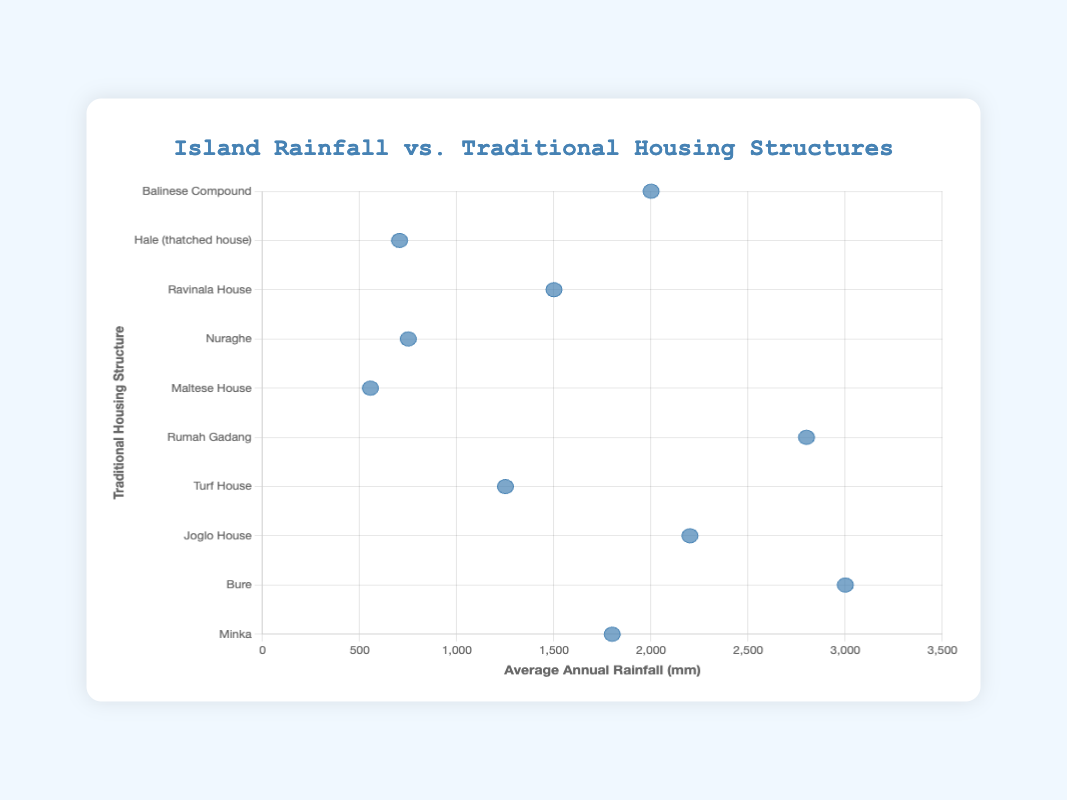What's the title of the chart? The title is prominently displayed at the top center of the chart, reading "Island Rainfall vs. Traditional Housing Structures".
Answer: Island Rainfall vs. Traditional Housing Structures What measurement is represented on the x-axis? The x-axis title reads "Average Annual Rainfall (mm)", indicating that it measures the average annual rainfall in millimeters.
Answer: Average Annual Rainfall (mm) Which traditional housing structure is associated with the highest average annual rainfall? The housing structure labeled "Bure" is at the highest position on the x-axis, which corresponds to Fiji with 3000 mm of rainfall.
Answer: Bure List the islands that have an average annual rainfall greater than 2000 mm. By checking the data points to the right of the 2000 mm mark, the islands are Sumatra (2800 mm), Java (2200 mm), and Fiji (3000 mm).
Answer: Sumatra, Java, Fiji Which island's traditional housing structure has the lowest average annual rainfall? The data point closest to zero on the x-axis represents the "Maltese House" for Malta, with 555 mm of rainfall.
Answer: Malta Is there any island with similar average annual rainfall to Sardinia? If yes, name it. Sardinia's average annual rainfall is 750 mm. The island closest to this value is Honolulu with 705 mm, as both are positioned similarly on the x-axis.
Answer: Honolulu What is the average annual rainfall for the island having a traditional housing structure known as "Minka"? Refer to the "Minka" data point, which corresponds to Kyushu with an average annual rainfall of 1800 mm.
Answer: 1800 mm Compare the average annual rainfall between Iceland and Madagascar. Which island receives more rainfall? The "Turf House" representing Iceland is at 1250 mm, and the "Ravinala House" representing Madagascar is at 1500 mm. Therefore, Madagascar receives more rainfall.
Answer: Madagascar Calculate the difference in average annual rainfall between Bali and Sumatra. Bali has 2000 mm of rainfall, and Sumatra has 2800 mm. The difference is 2800 - 2000 = 800 mm.
Answer: 800 mm Do islands with thatched traditional housing structures tend to have higher or lower average annual rainfall compared to other types? By observing the specific housing structures like "Hale" and "Bure," we see that "Bure" (Fiji) has a very high rainfall of 3000 mm while "Hale" (Honolulu) has 705 mm. The overall trend is not clear and varies by island.
Answer: It varies 